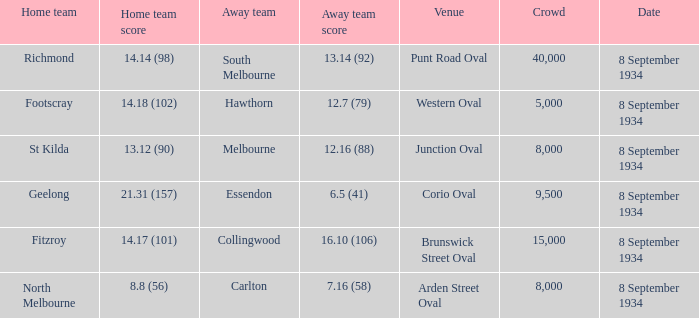When Melbourne was the Away team, what was their score? 12.16 (88). 